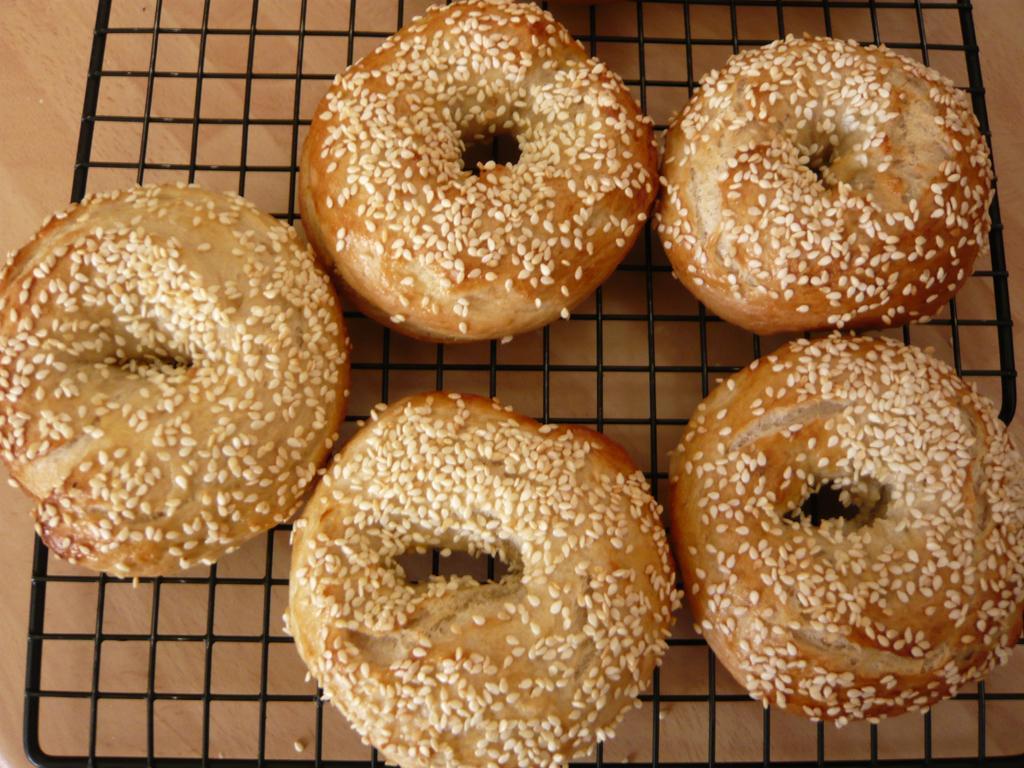How would you summarize this image in a sentence or two? In the center of the image there are donuts on the grill. 